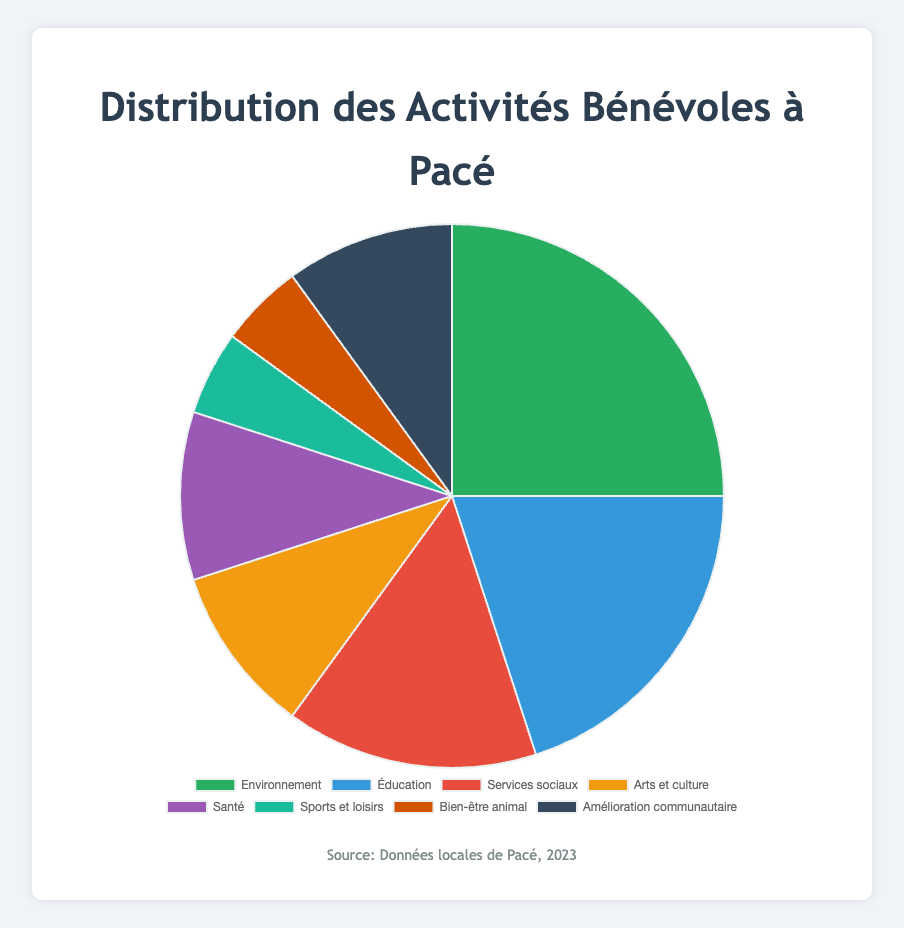What's the most common volunteer activity in Pacé? The pie chart shows that the largest portion is dedicated to "Environmental" activities, which occupies 25% of the total.
Answer: Environmental Which categories have the same percentage distribution? By examining the pie chart, we see that both "Health" and "Arts and Culture" each account for 10% of the total volunteer activities.
Answer: Health, Arts and Culture What is the total percentage of volunteer activities dedicated to "Environmental" and "Education"? The percentage for "Environmental" is 25%, and for "Education" it is 20%. Adding these together, 25% + 20% = 45%.
Answer: 45% How do the percentages for "Social Services" and "Community Improvement" compare? The pie chart shows that "Social Services" is 15%, and "Community Improvement" is 10%. Therefore, "Social Services" is 5% higher than "Community Improvement".
Answer: Social Services is 5% higher Which category occupies the smallest portion of volunteer activities? The smallest portions of the pie chart, each with 5%, are "Sports and Recreation" and "Animal Welfare".
Answer: Sports and Recreation, Animal Welfare What is the sum of percentages for "Social Services," "Arts and Culture," and "Health"? The percentages are 15% for "Social Services," 10% for "Arts and Culture," and 10% for "Health." Adding them together gives 15% + 10% + 10% = 35%.
Answer: 35% How many distinct categories are represented in the pie chart? A quick count of the segments in the pie chart reveals that there are eight distinct categories represented.
Answer: 8 Which category is represented by the green color in the pie chart? The green color in the pie chart corresponds to the "Environmental" category.
Answer: Environmental What percentage of volunteer activities are dedicated to categories other than "Environmental"? Subtracting the "Environmental" percentage (25%) from the total 100%: 100% - 25% = 75%.
Answer: 75% 